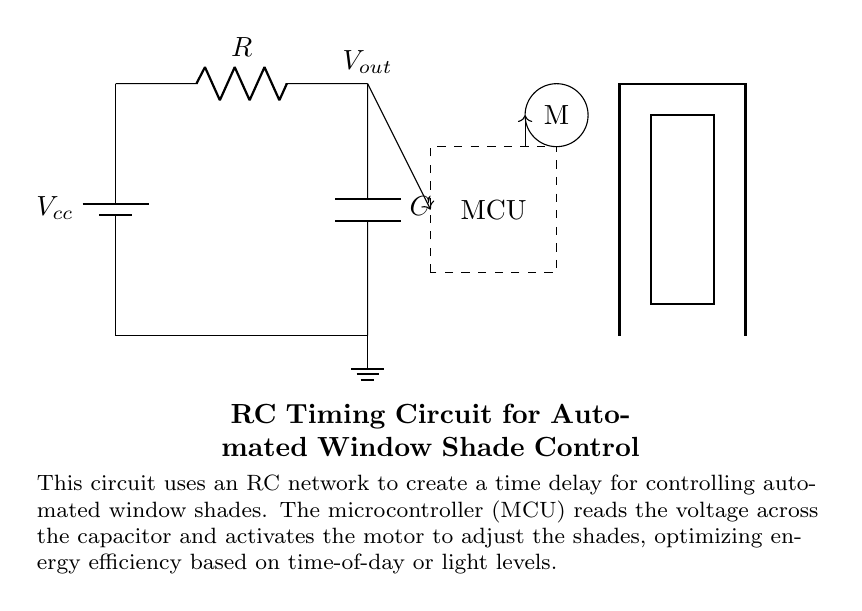What component is used to create time delay in this circuit? The time delay is created by the capacitor in conjunction with the resistor, as the charging and discharging of the capacitor determines the timing interval.
Answer: capacitor What type of motor is connected in this circuit? The circuit diagram suggests that the motor appears to be a standard DC motor (typical representation in circuits), used here to automate the movement of the window shades.
Answer: DC motor What does the microcontroller do in this circuit? The microcontroller reads the voltage across the capacitor and activates the motor to adjust the window shades, thus optimizing energy efficiency.
Answer: controls the motor Which components are involved in determining the timing of the RC circuit? The timing of the RC circuit is determined by both the resistor and the capacitor, where the time constant is the product of the resistance and capacitance values.
Answer: resistor and capacitor What is the function of the battery in this circuit? The battery provides the necessary voltage supply to power the circuit elements, allowing the circuit to function properly.
Answer: provides voltage How does the capacitor influence the window shade operation? The capacitor charges up over time and its voltage is monitored by the microcontroller, which determines when to activate the motor to adjust the shades, allowing for timely responses to light levels.
Answer: controls timing What is the output voltage in the circuit represented? The output voltage (Vout) is taken across the capacitor, which varies as it charges or discharges over time, influencing when the microcontroller activates the motor.
Answer: Vout 